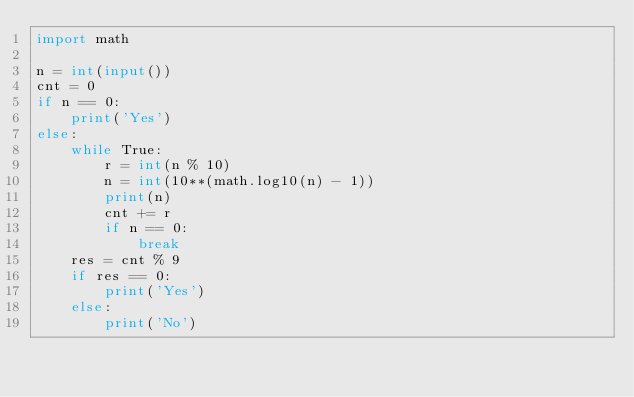<code> <loc_0><loc_0><loc_500><loc_500><_Python_>import math

n = int(input())
cnt = 0
if n == 0:
    print('Yes')
else:
    while True:
        r = int(n % 10)
        n = int(10**(math.log10(n) - 1))
        print(n)
        cnt += r
        if n == 0:
            break
    res = cnt % 9
    if res == 0:
        print('Yes')
    else:
        print('No')</code> 